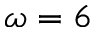Convert formula to latex. <formula><loc_0><loc_0><loc_500><loc_500>\omega = 6</formula> 